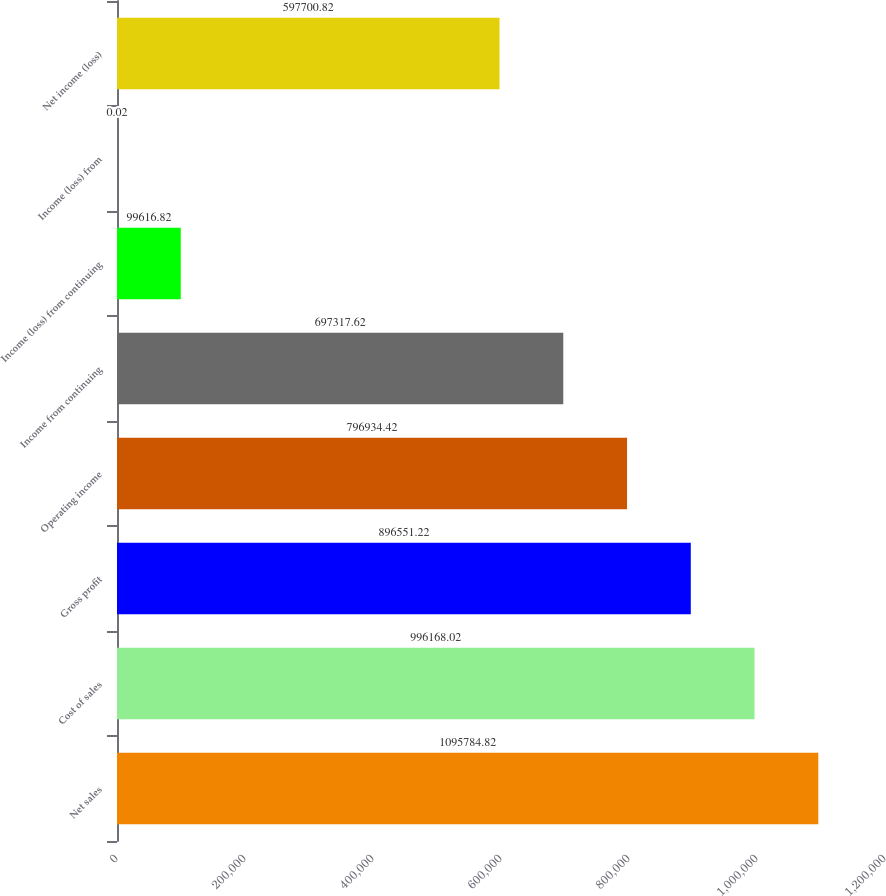Convert chart. <chart><loc_0><loc_0><loc_500><loc_500><bar_chart><fcel>Net sales<fcel>Cost of sales<fcel>Gross profit<fcel>Operating income<fcel>Income from continuing<fcel>Income (loss) from continuing<fcel>Income (loss) from<fcel>Net income (loss)<nl><fcel>1.09578e+06<fcel>996168<fcel>896551<fcel>796934<fcel>697318<fcel>99616.8<fcel>0.02<fcel>597701<nl></chart> 